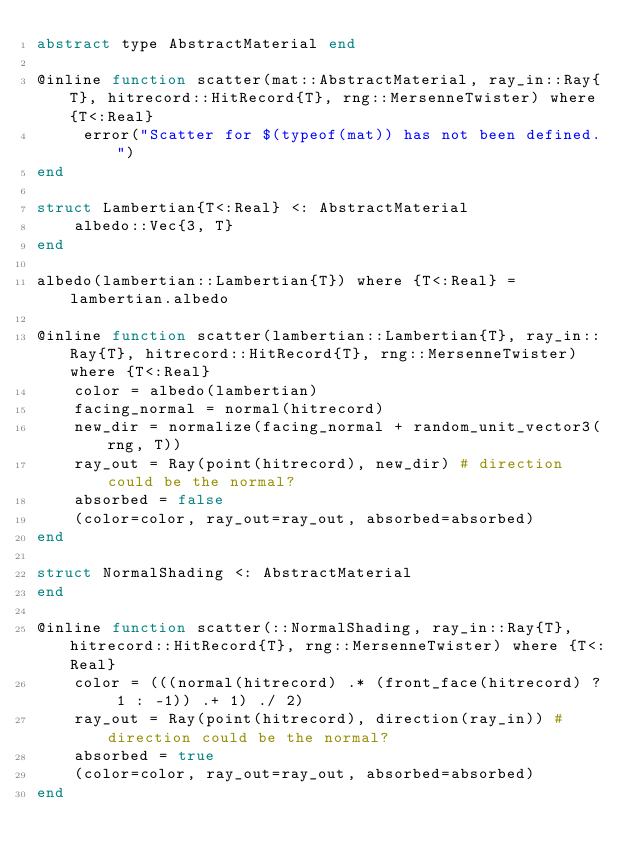Convert code to text. <code><loc_0><loc_0><loc_500><loc_500><_Julia_>abstract type AbstractMaterial end

@inline function scatter(mat::AbstractMaterial, ray_in::Ray{T}, hitrecord::HitRecord{T}, rng::MersenneTwister) where {T<:Real} 
     error("Scatter for $(typeof(mat)) has not been defined.")
end

struct Lambertian{T<:Real} <: AbstractMaterial
    albedo::Vec{3, T}
end

albedo(lambertian::Lambertian{T}) where {T<:Real} = lambertian.albedo

@inline function scatter(lambertian::Lambertian{T}, ray_in::Ray{T}, hitrecord::HitRecord{T}, rng::MersenneTwister) where {T<:Real}
    color = albedo(lambertian)
    facing_normal = normal(hitrecord)
    new_dir = normalize(facing_normal + random_unit_vector3(rng, T))
    ray_out = Ray(point(hitrecord), new_dir) # direction could be the normal?
    absorbed = false
    (color=color, ray_out=ray_out, absorbed=absorbed)
end

struct NormalShading <: AbstractMaterial
end

@inline function scatter(::NormalShading, ray_in::Ray{T}, hitrecord::HitRecord{T}, rng::MersenneTwister) where {T<:Real}
    color = (((normal(hitrecord) .* (front_face(hitrecord) ? 1 : -1)) .+ 1) ./ 2)
    ray_out = Ray(point(hitrecord), direction(ray_in)) # direction could be the normal?
    absorbed = true
    (color=color, ray_out=ray_out, absorbed=absorbed)
end

</code> 